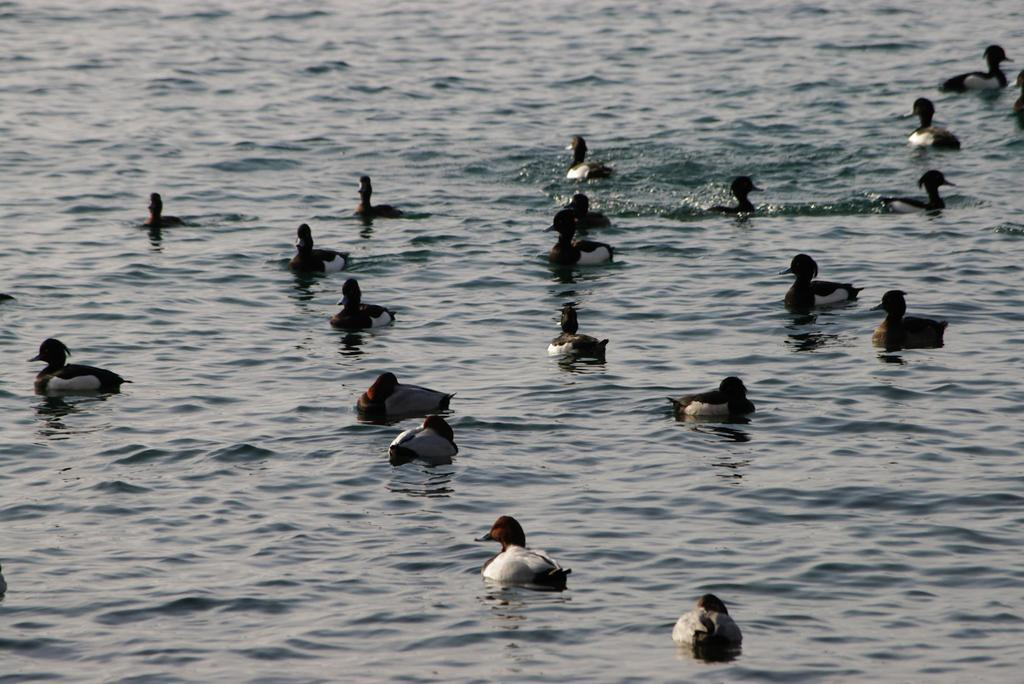What type of animals can be seen in the image? Birds can be seen in the image. Where are the birds situated in the image? The birds are in the water. What type of metal is the minister using to catch the sun in the image? There is no minister, sun, or metal present in the image; it features birds in the water. 